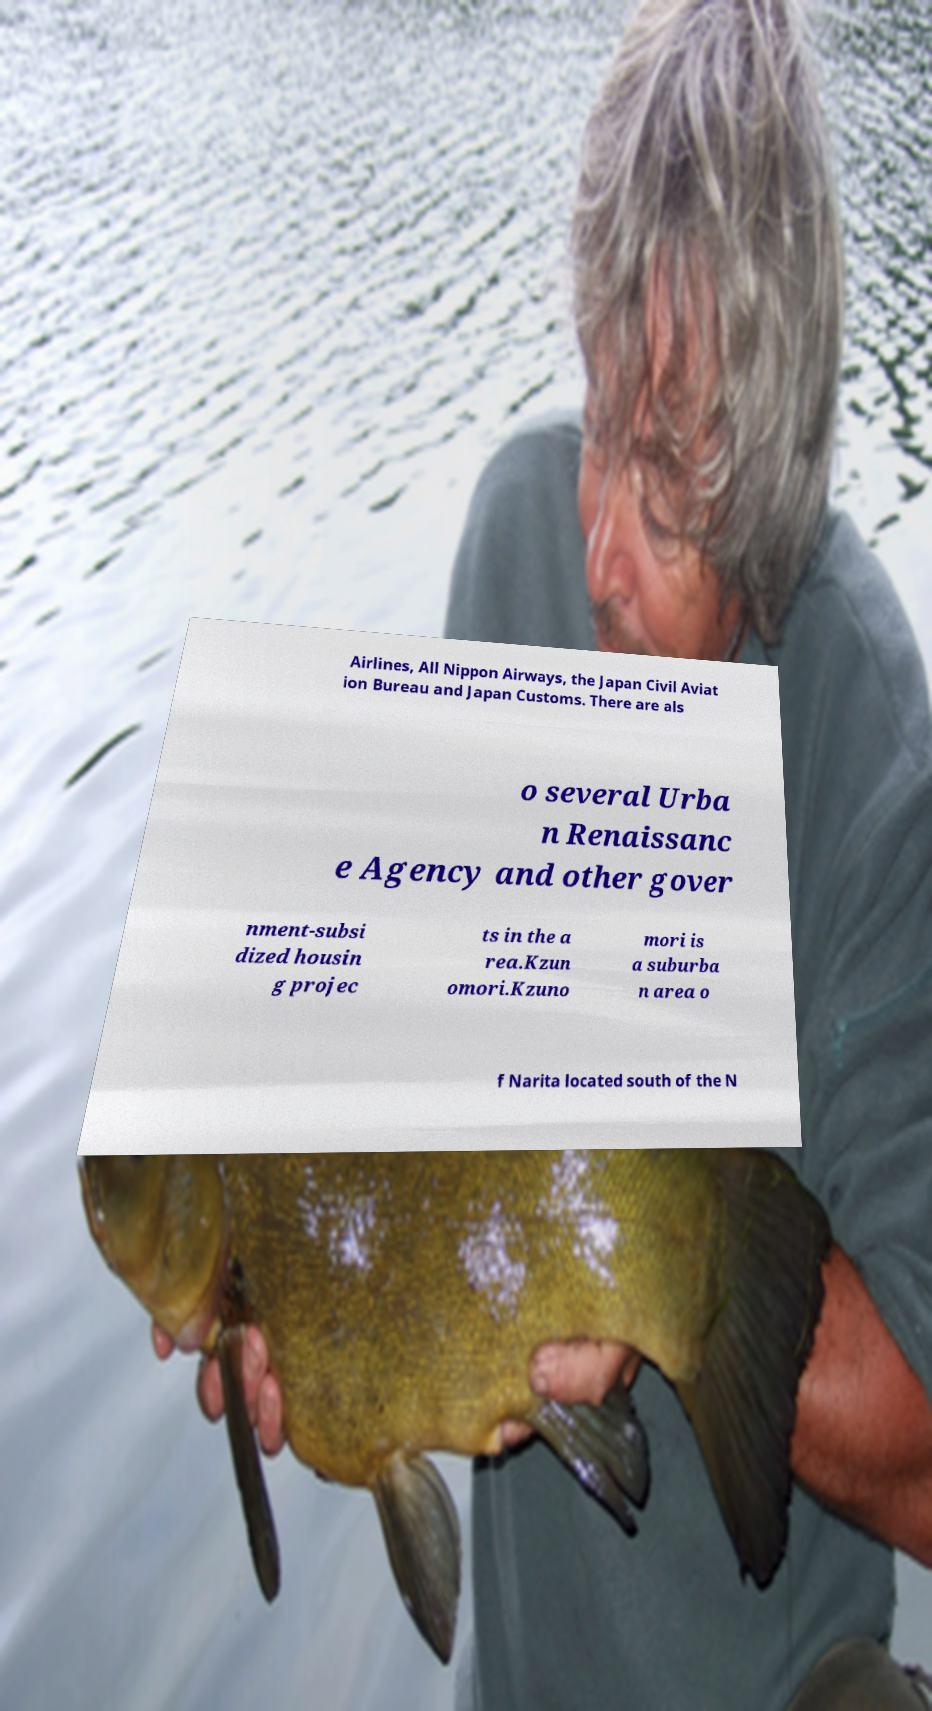There's text embedded in this image that I need extracted. Can you transcribe it verbatim? Airlines, All Nippon Airways, the Japan Civil Aviat ion Bureau and Japan Customs. There are als o several Urba n Renaissanc e Agency and other gover nment-subsi dized housin g projec ts in the a rea.Kzun omori.Kzuno mori is a suburba n area o f Narita located south of the N 